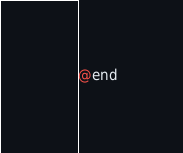<code> <loc_0><loc_0><loc_500><loc_500><_C_>
@end

</code> 